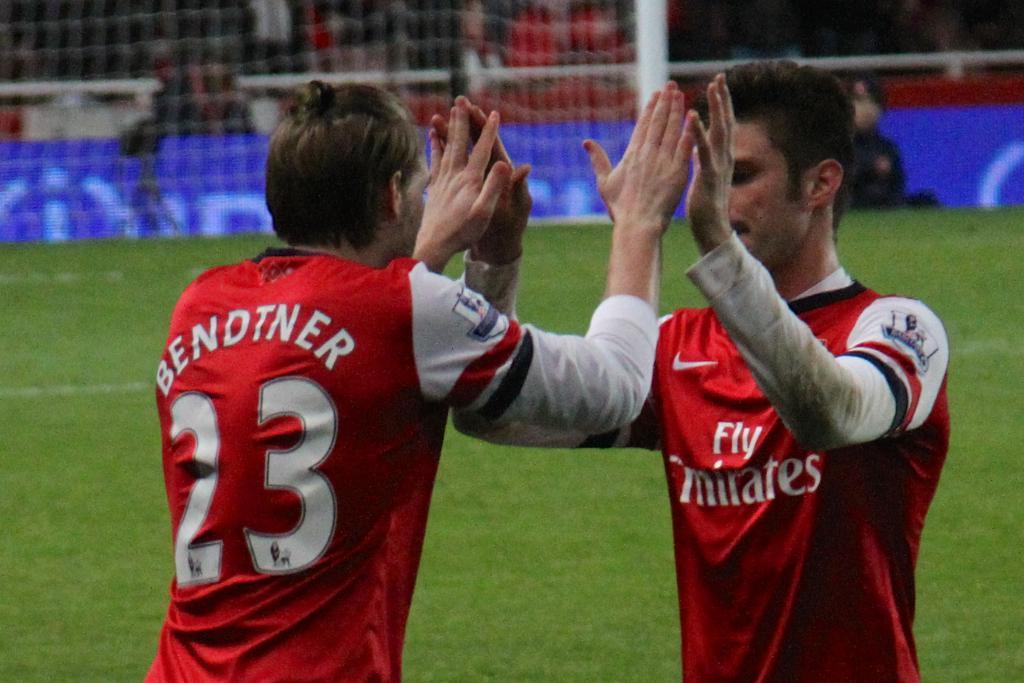What is the on the jersey of the player on the right?
Offer a very short reply. Fly emirates. 